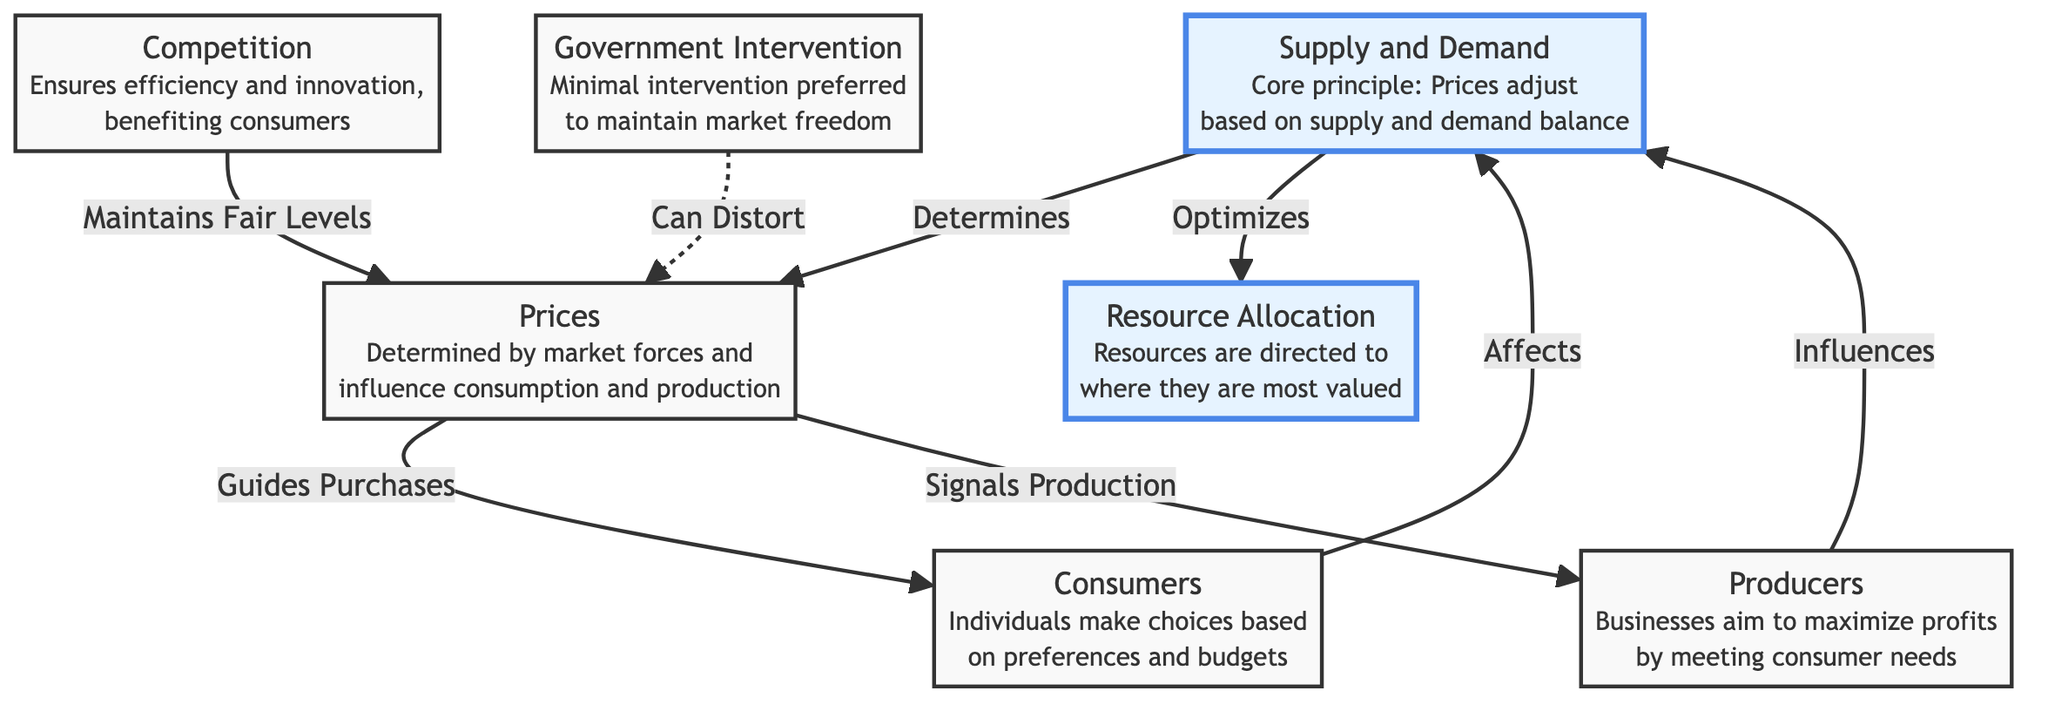What is the core principle represented by the supply and demand node? According to the diagram, the core principle represented by the supply and demand node is that prices adjust based on the supply and demand balance.
Answer: Prices adjust based on supply and demand balance How do consumers affect supply and demand? The diagram outlines that consumers affect supply and demand by making choices based on their preferences and budgets.
Answer: By making choices based on preferences and budgets What does the competition node ensure in the market? The competition node in the diagram indicates that it ensures efficiency and innovation, which ultimately benefits consumers.
Answer: Efficiency and innovation Which node signals production? Referring to the diagram, the prices node is the one that signals production to producers.
Answer: Prices What is meant by resource allocation in this context? Resource allocation, as indicated in the diagram, means that resources are directed to where they are most valued based on market dynamics.
Answer: Resources are directed to where they are most valued Which arrows in the diagram represent influences rather than direct effects? The arrow from producers to supply and demand and the arrow from consumers to supply and demand represent influences rather than direct effects.
Answer: Producers and consumers influence supply and demand How does government intervention affect prices according to the diagram? The diagram shows that government intervention can distort prices, indicating a negative impact on market equilibrium.
Answer: Can distort prices What is the relationship between supply and demand and resource allocation? The diagram establishes that supply and demand optimizes resource allocation, suggesting a direct causal relationship where market forces align resources with value.
Answer: Optimizes resource allocation How many nodes are displayed in the diagram? Counting the visual elements in the diagram, there are seven nodes present related to the principles of free market economics.
Answer: Seven nodes 